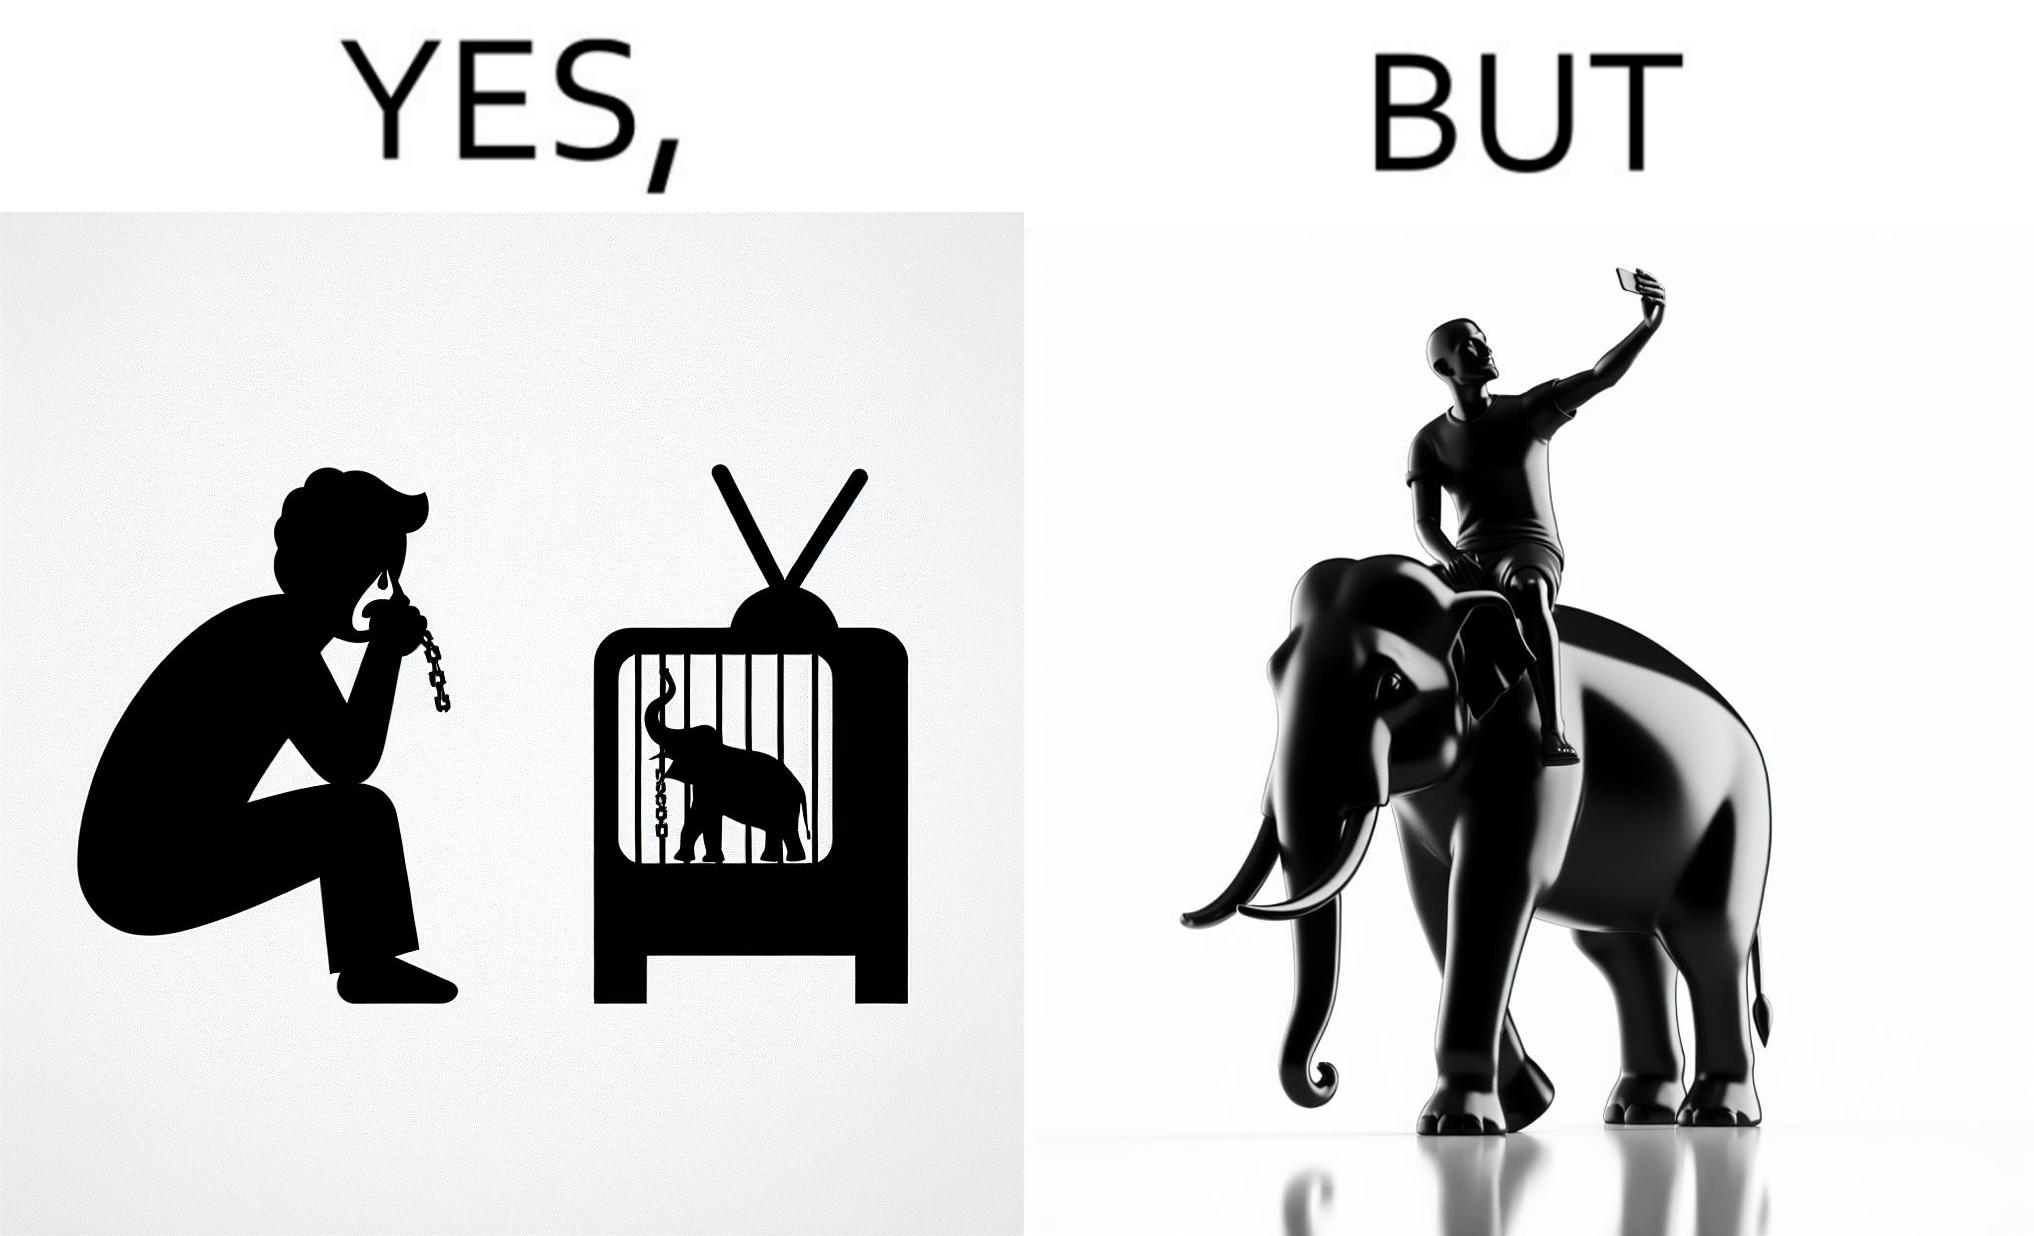Explain the humor or irony in this image. The image is ironic, because the people who get sentimental over imprisoned animal while watching TV shows often feel okay when using animals for labor 